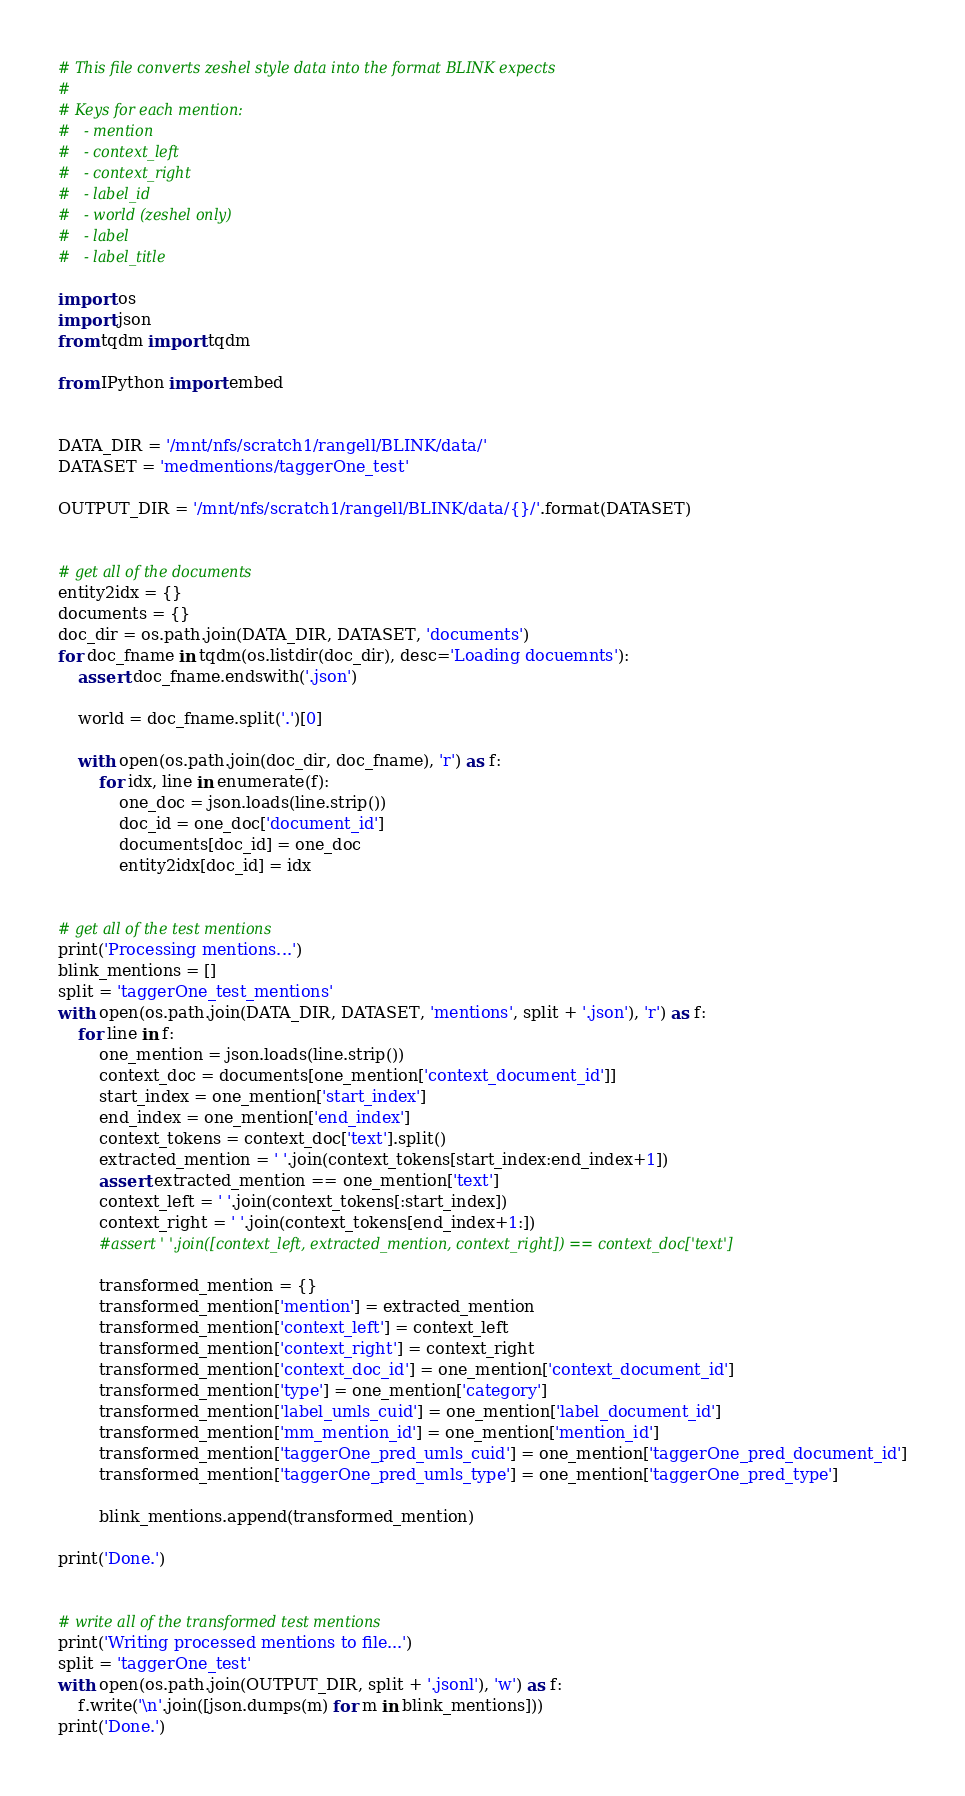Convert code to text. <code><loc_0><loc_0><loc_500><loc_500><_Python_># This file converts zeshel style data into the format BLINK expects
#
# Keys for each mention:
#   - mention
#   - context_left
#   - context_right
#   - label_id
#   - world (zeshel only)
#   - label
#   - label_title

import os
import json
from tqdm import tqdm

from IPython import embed


DATA_DIR = '/mnt/nfs/scratch1/rangell/BLINK/data/'
DATASET = 'medmentions/taggerOne_test'

OUTPUT_DIR = '/mnt/nfs/scratch1/rangell/BLINK/data/{}/'.format(DATASET)


# get all of the documents
entity2idx = {}
documents = {}
doc_dir = os.path.join(DATA_DIR, DATASET, 'documents')
for doc_fname in tqdm(os.listdir(doc_dir), desc='Loading docuemnts'):
    assert doc_fname.endswith('.json')

    world = doc_fname.split('.')[0]

    with open(os.path.join(doc_dir, doc_fname), 'r') as f:
        for idx, line in enumerate(f):
            one_doc = json.loads(line.strip())
            doc_id = one_doc['document_id']
            documents[doc_id] = one_doc
            entity2idx[doc_id] = idx


# get all of the test mentions
print('Processing mentions...')
blink_mentions = []
split = 'taggerOne_test_mentions'
with open(os.path.join(DATA_DIR, DATASET, 'mentions', split + '.json'), 'r') as f:
    for line in f:
        one_mention = json.loads(line.strip())
        context_doc = documents[one_mention['context_document_id']]
        start_index = one_mention['start_index']
        end_index = one_mention['end_index']
        context_tokens = context_doc['text'].split()
        extracted_mention = ' '.join(context_tokens[start_index:end_index+1])
        assert extracted_mention == one_mention['text']
        context_left = ' '.join(context_tokens[:start_index])
        context_right = ' '.join(context_tokens[end_index+1:])
        #assert ' '.join([context_left, extracted_mention, context_right]) == context_doc['text']

        transformed_mention = {}
        transformed_mention['mention'] = extracted_mention
        transformed_mention['context_left'] = context_left
        transformed_mention['context_right'] = context_right
        transformed_mention['context_doc_id'] = one_mention['context_document_id']
        transformed_mention['type'] = one_mention['category']
        transformed_mention['label_umls_cuid'] = one_mention['label_document_id']
        transformed_mention['mm_mention_id'] = one_mention['mention_id']
        transformed_mention['taggerOne_pred_umls_cuid'] = one_mention['taggerOne_pred_document_id']
        transformed_mention['taggerOne_pred_umls_type'] = one_mention['taggerOne_pred_type']

        blink_mentions.append(transformed_mention)

print('Done.')


# write all of the transformed test mentions
print('Writing processed mentions to file...')
split = 'taggerOne_test'
with open(os.path.join(OUTPUT_DIR, split + '.jsonl'), 'w') as f:
    f.write('\n'.join([json.dumps(m) for m in blink_mentions]))
print('Done.')
</code> 